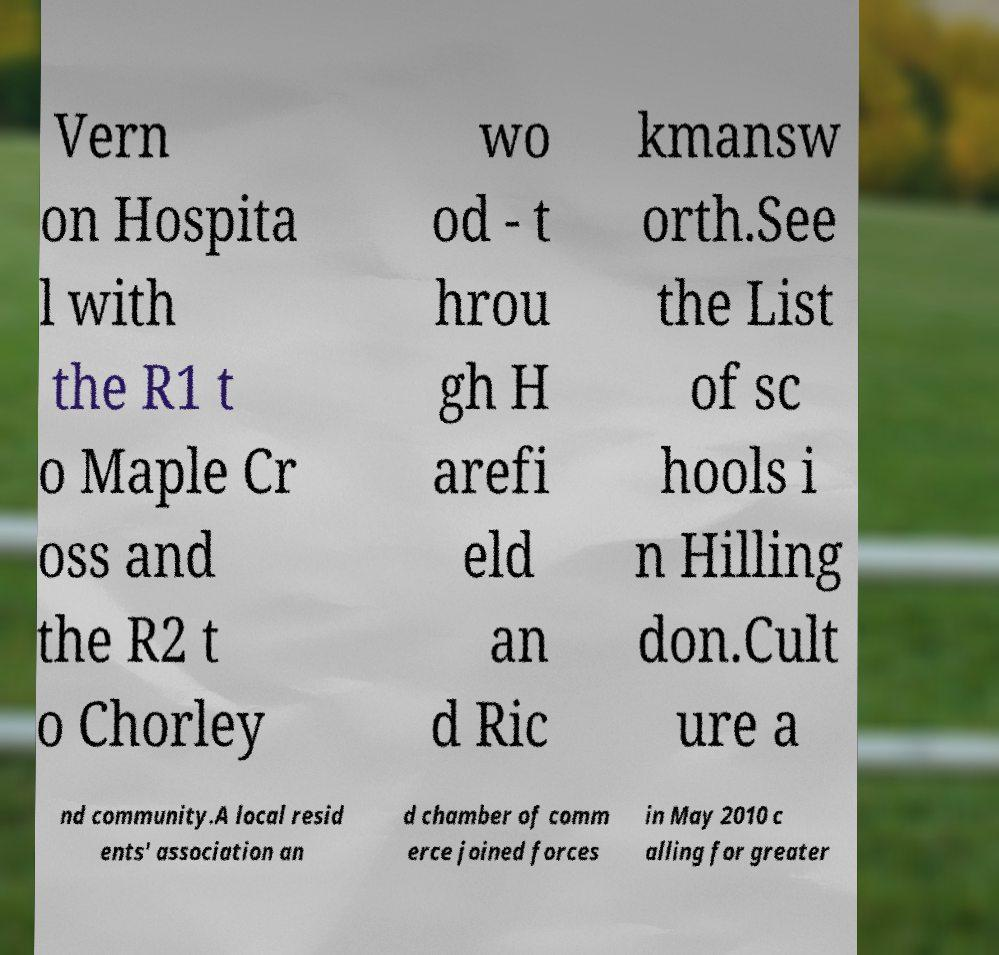Please read and relay the text visible in this image. What does it say? Vern on Hospita l with the R1 t o Maple Cr oss and the R2 t o Chorley wo od - t hrou gh H arefi eld an d Ric kmansw orth.See the List of sc hools i n Hilling don.Cult ure a nd community.A local resid ents' association an d chamber of comm erce joined forces in May 2010 c alling for greater 